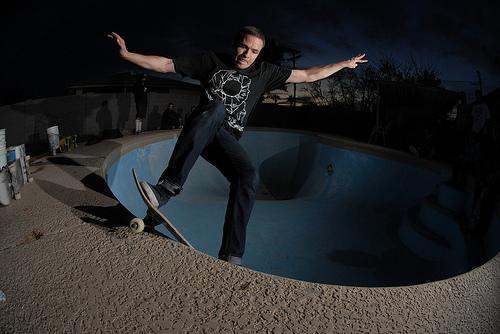How many people are pictured?
Give a very brief answer. 1. 